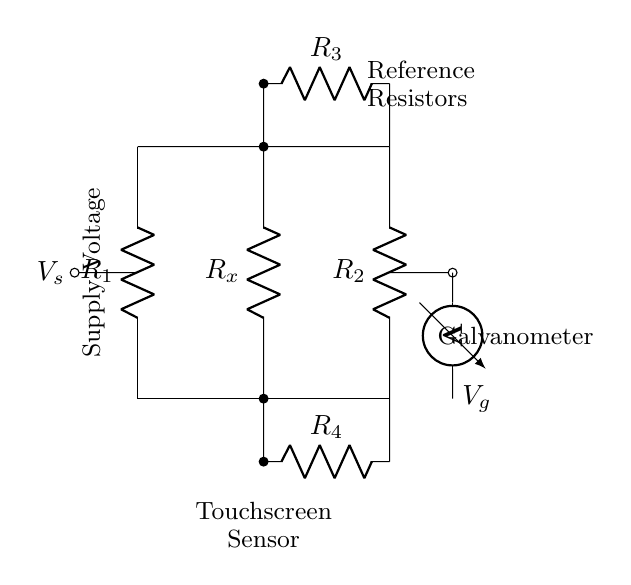What does R1 represent? R1 represents one of the resistors in the Wheatstone bridge circuit, specifically one of the reference resistors for comparison with the unknown resistance.
Answer: Resistor What is the role of Rx in the circuit? Rx is the resistive sensor, where the resistance is being measured relative to the reference resistors R1 and R2 to determine its value based on the balance of the bridge.
Answer: Resistive sensor What is measured across the galvanometer? The galvanometer measures the voltage difference between the two midpoints of the bridge, which indicates if the bridge is balanced or if there is a voltage imbalance due to changes in Rx.
Answer: Voltage difference How many resistors are in the Wheatstone bridge? There are a total of four resistors in the Wheatstone bridge circuit, which includes two reference resistors as well as the unknown resistor and another resistor for balance.
Answer: Four resistors What does Vs represent in the circuit? Vs represents the supply voltage provided to the Wheatstone bridge circuit, powering the entire measurement system and enabling current flow through the resistors.
Answer: Supply voltage What is the function of R3 and R4? R3 and R4 are used as additional resistors that help to balance the bridge and allow for accurate measurement of the unknown resistance. They can be adjusted to reach the desired balance.
Answer: Balancing resistors 